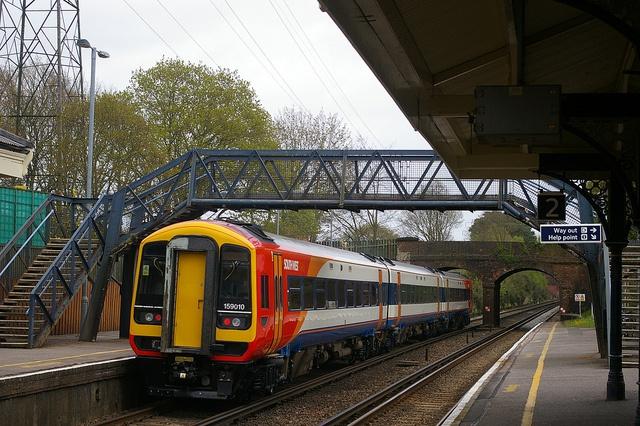Describe the objects in this image and their specific colors. I can see a train in darkgray, black, olive, and brown tones in this image. 